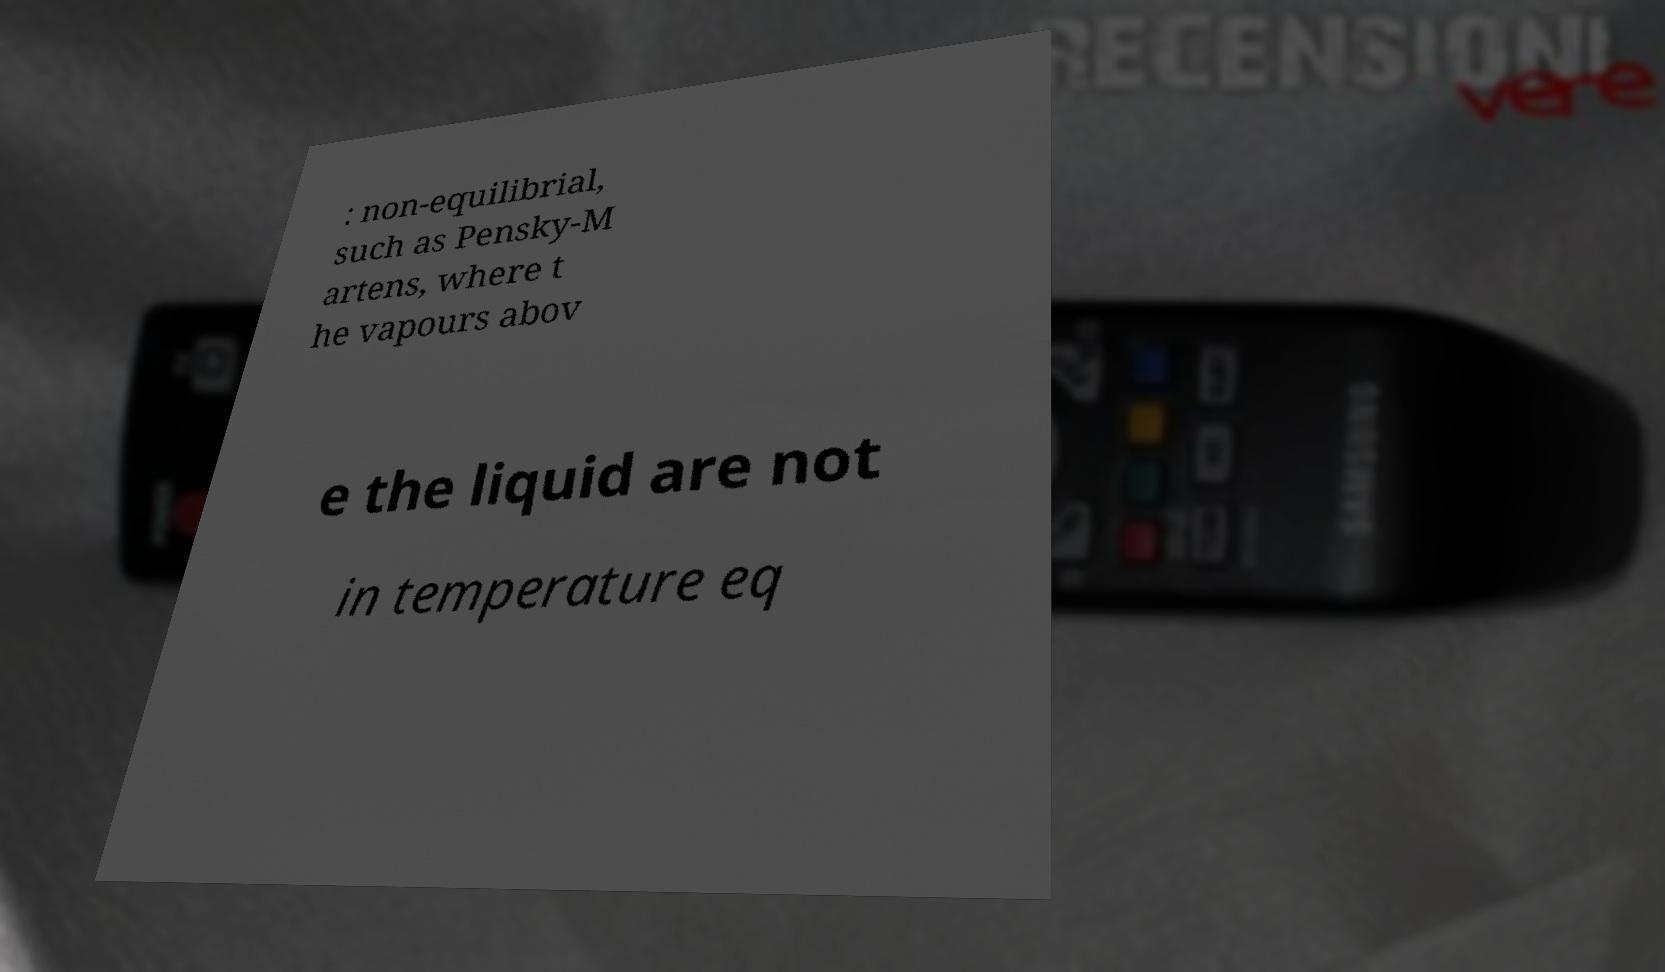Please read and relay the text visible in this image. What does it say? : non-equilibrial, such as Pensky-M artens, where t he vapours abov e the liquid are not in temperature eq 